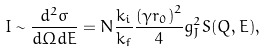Convert formula to latex. <formula><loc_0><loc_0><loc_500><loc_500>I \sim \frac { d ^ { 2 } \sigma } { d \Omega d E } = N \frac { k _ { i } } { k _ { f } } \frac { \left ( \gamma r _ { 0 } \right ) ^ { 2 } } 4 g _ { J } ^ { 2 } S ( { Q } , E ) ,</formula> 